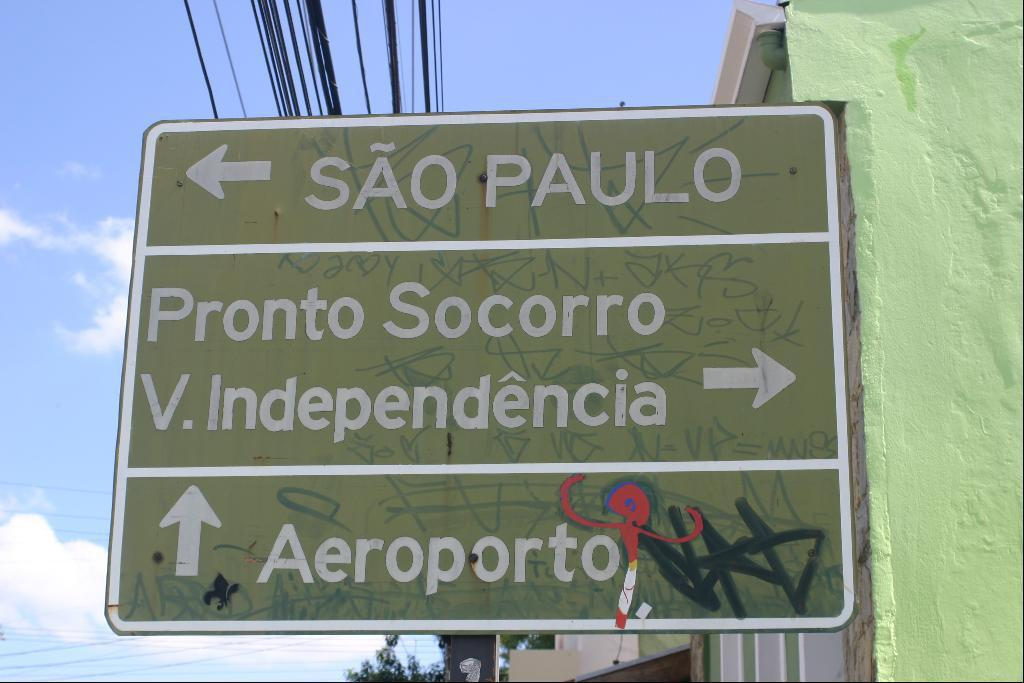What is present on the sign board in the image? There is text on the sign board in the image. What else can be seen in the image besides the sign board? There are wires and a wall on the right side of the image. How would you describe the sky in the image? The sky is cloudy in the image. Can you see a monkey shaking a quince in the image? No, there is no monkey or quince present in the image. 